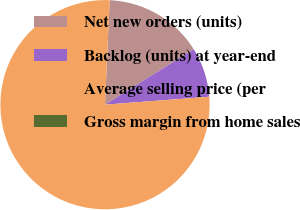Convert chart. <chart><loc_0><loc_0><loc_500><loc_500><pie_chart><fcel>Net new orders (units)<fcel>Backlog (units) at year-end<fcel>Average selling price (per<fcel>Gross margin from home sales<nl><fcel>15.39%<fcel>7.69%<fcel>76.92%<fcel>0.0%<nl></chart> 